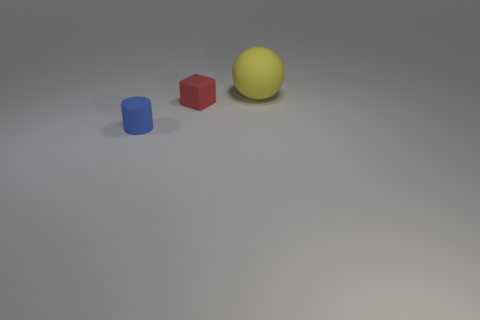Add 1 small cyan spheres. How many objects exist? 4 Subtract all balls. How many objects are left? 2 Add 1 blue cylinders. How many blue cylinders are left? 2 Add 1 tiny gray matte cubes. How many tiny gray matte cubes exist? 1 Subtract 0 red cylinders. How many objects are left? 3 Subtract all large red spheres. Subtract all matte things. How many objects are left? 0 